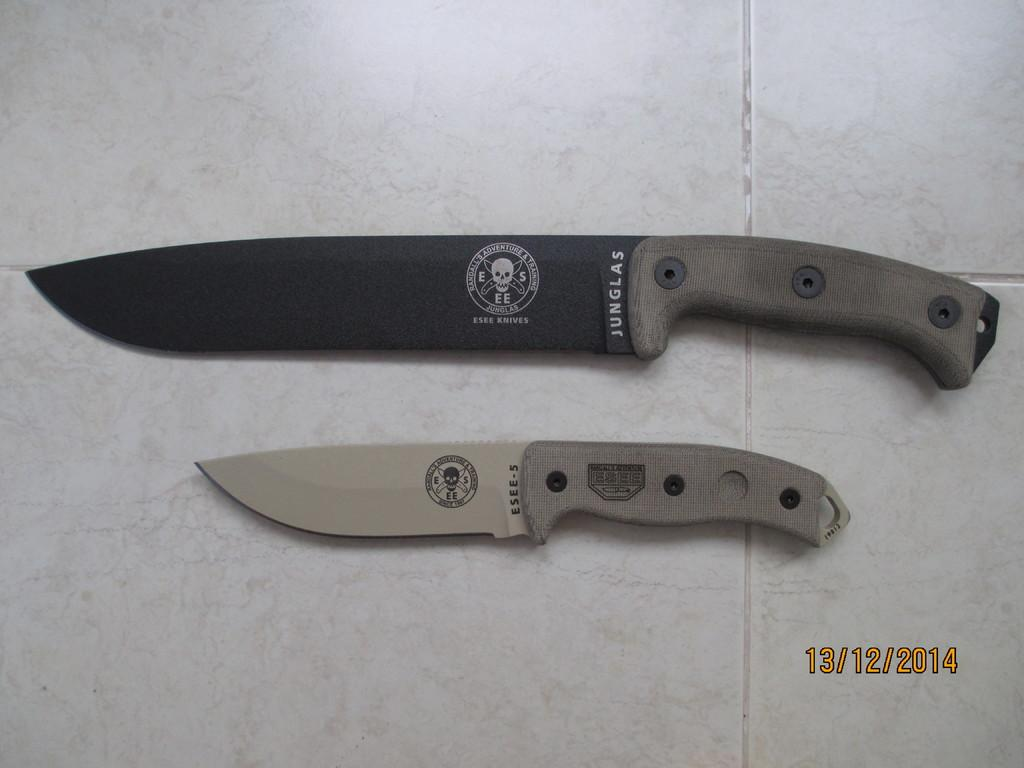Provide a one-sentence caption for the provided image. A black knife with a skull design and the words Junglas written on it with a silver knife below it with the Essee-5 written on it. 